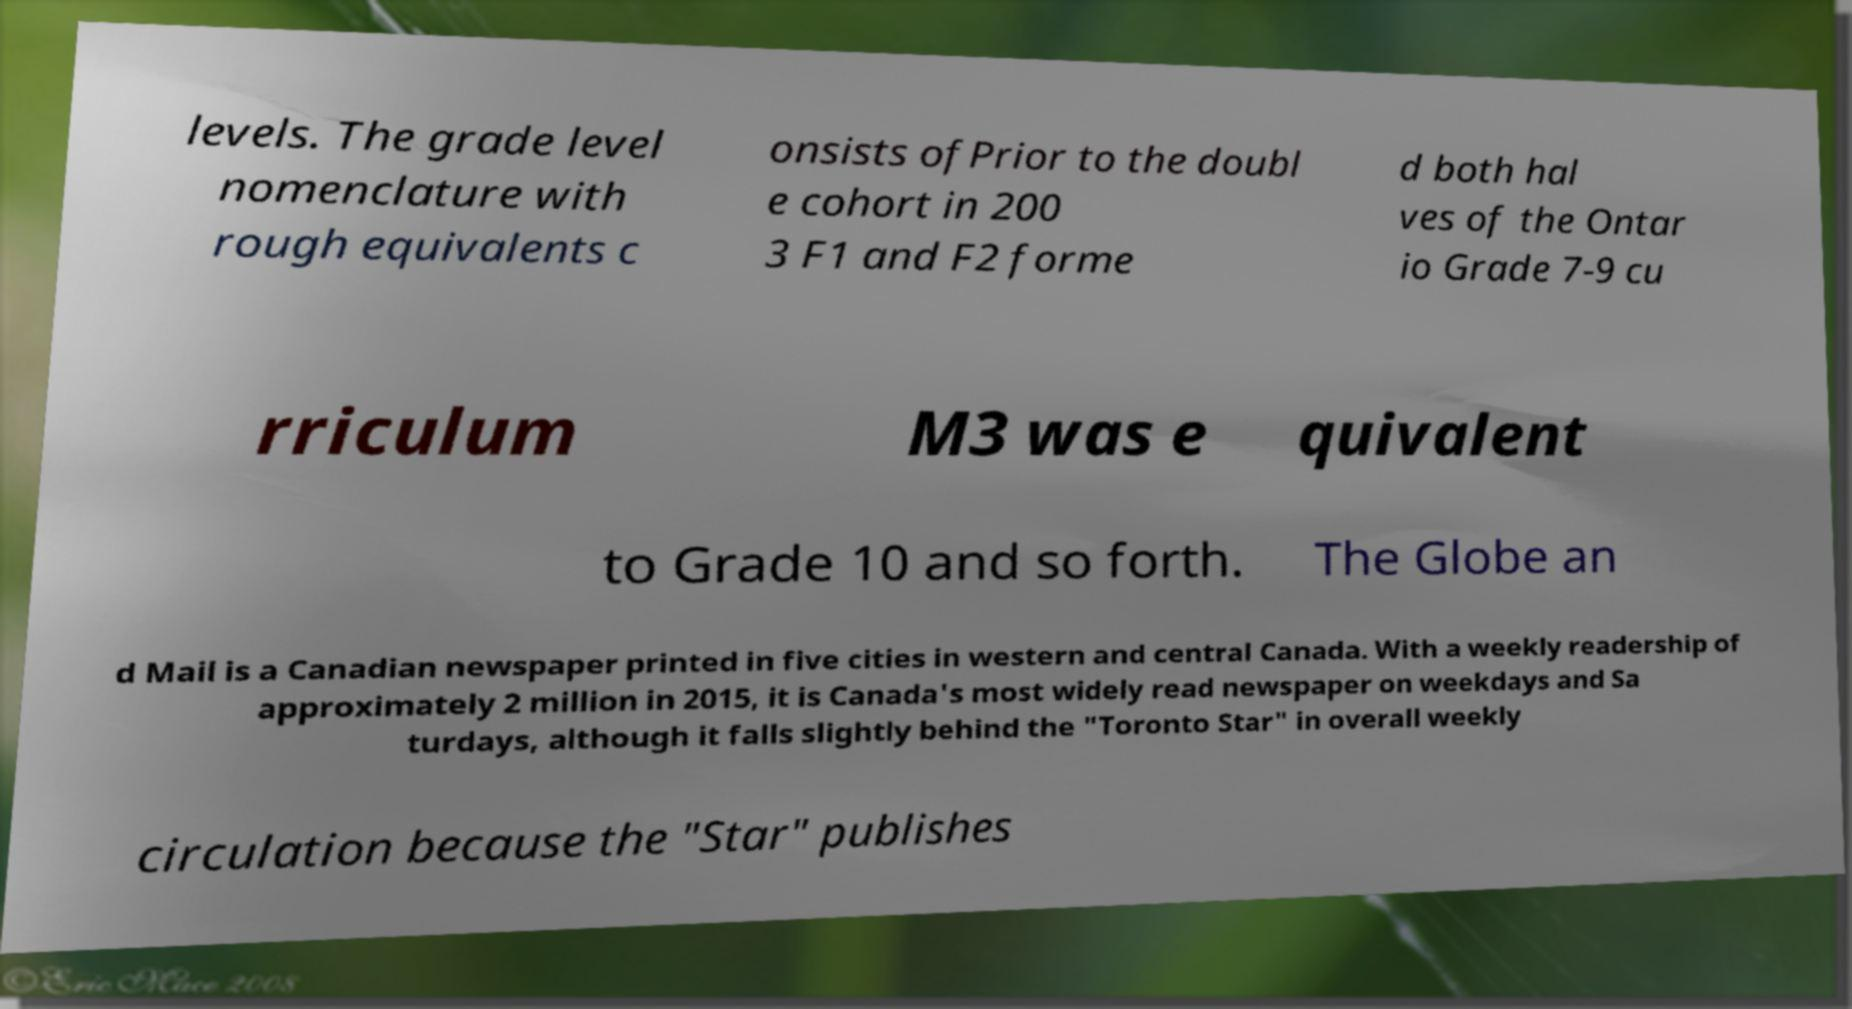What messages or text are displayed in this image? I need them in a readable, typed format. levels. The grade level nomenclature with rough equivalents c onsists ofPrior to the doubl e cohort in 200 3 F1 and F2 forme d both hal ves of the Ontar io Grade 7-9 cu rriculum M3 was e quivalent to Grade 10 and so forth. The Globe an d Mail is a Canadian newspaper printed in five cities in western and central Canada. With a weekly readership of approximately 2 million in 2015, it is Canada's most widely read newspaper on weekdays and Sa turdays, although it falls slightly behind the "Toronto Star" in overall weekly circulation because the "Star" publishes 